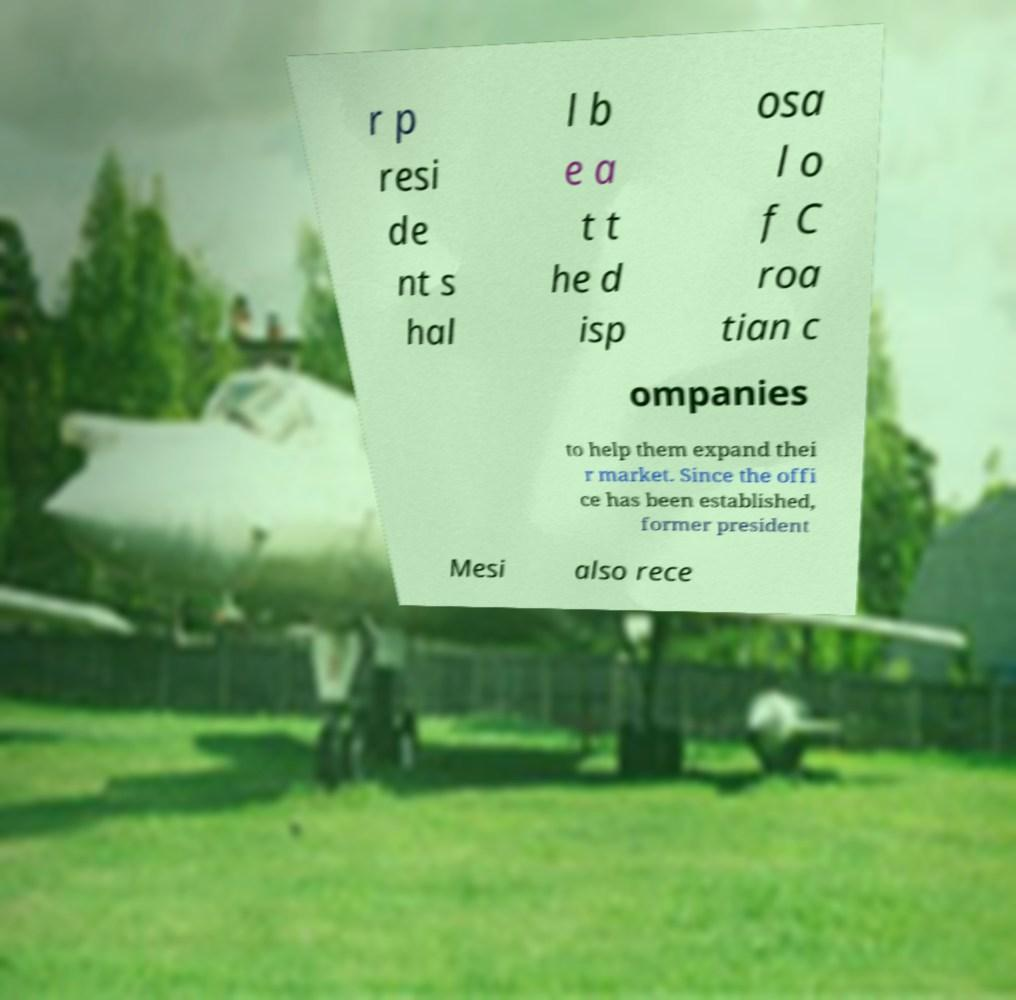There's text embedded in this image that I need extracted. Can you transcribe it verbatim? r p resi de nt s hal l b e a t t he d isp osa l o f C roa tian c ompanies to help them expand thei r market. Since the offi ce has been established, former president Mesi also rece 